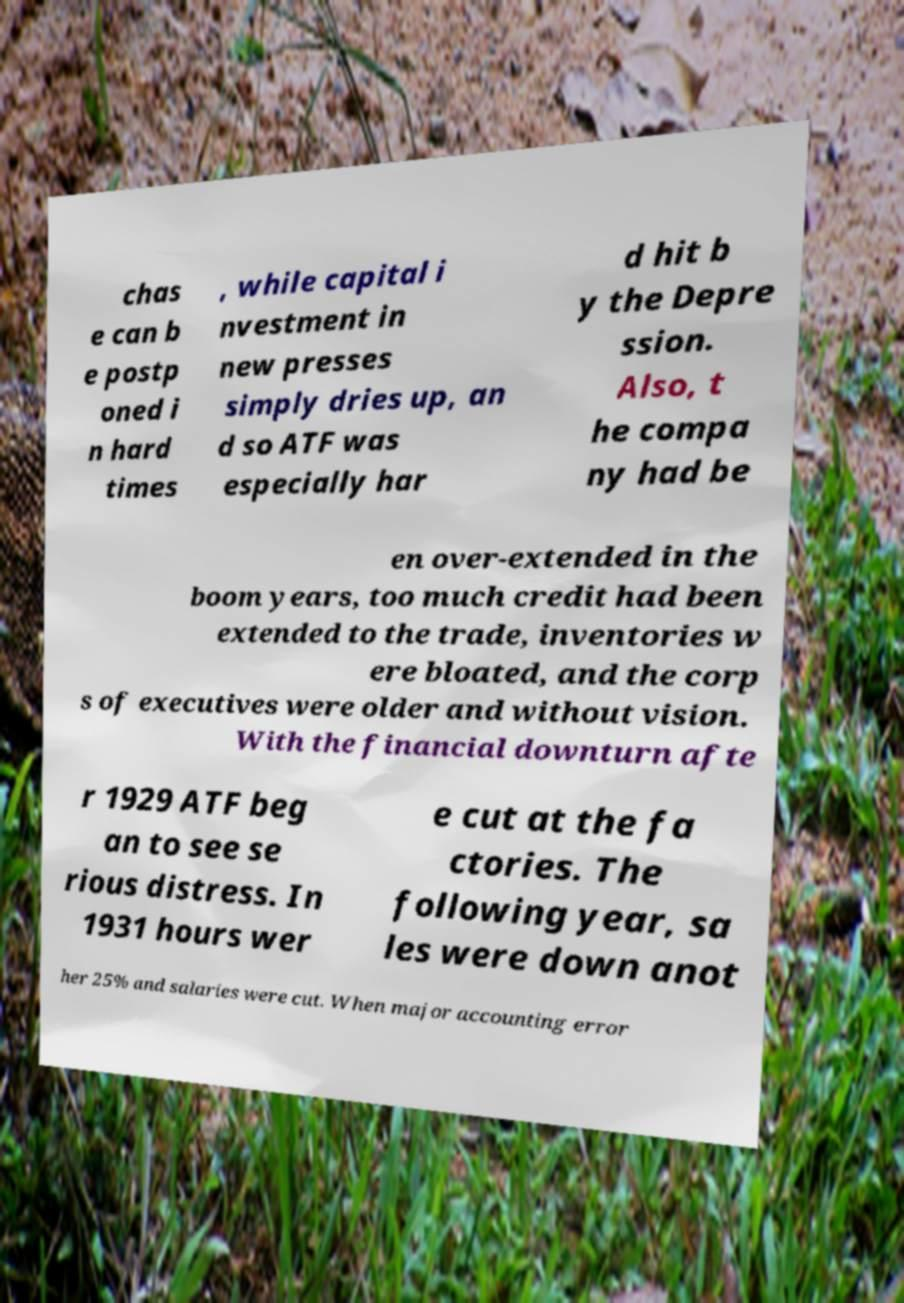I need the written content from this picture converted into text. Can you do that? chas e can b e postp oned i n hard times , while capital i nvestment in new presses simply dries up, an d so ATF was especially har d hit b y the Depre ssion. Also, t he compa ny had be en over-extended in the boom years, too much credit had been extended to the trade, inventories w ere bloated, and the corp s of executives were older and without vision. With the financial downturn afte r 1929 ATF beg an to see se rious distress. In 1931 hours wer e cut at the fa ctories. The following year, sa les were down anot her 25% and salaries were cut. When major accounting error 